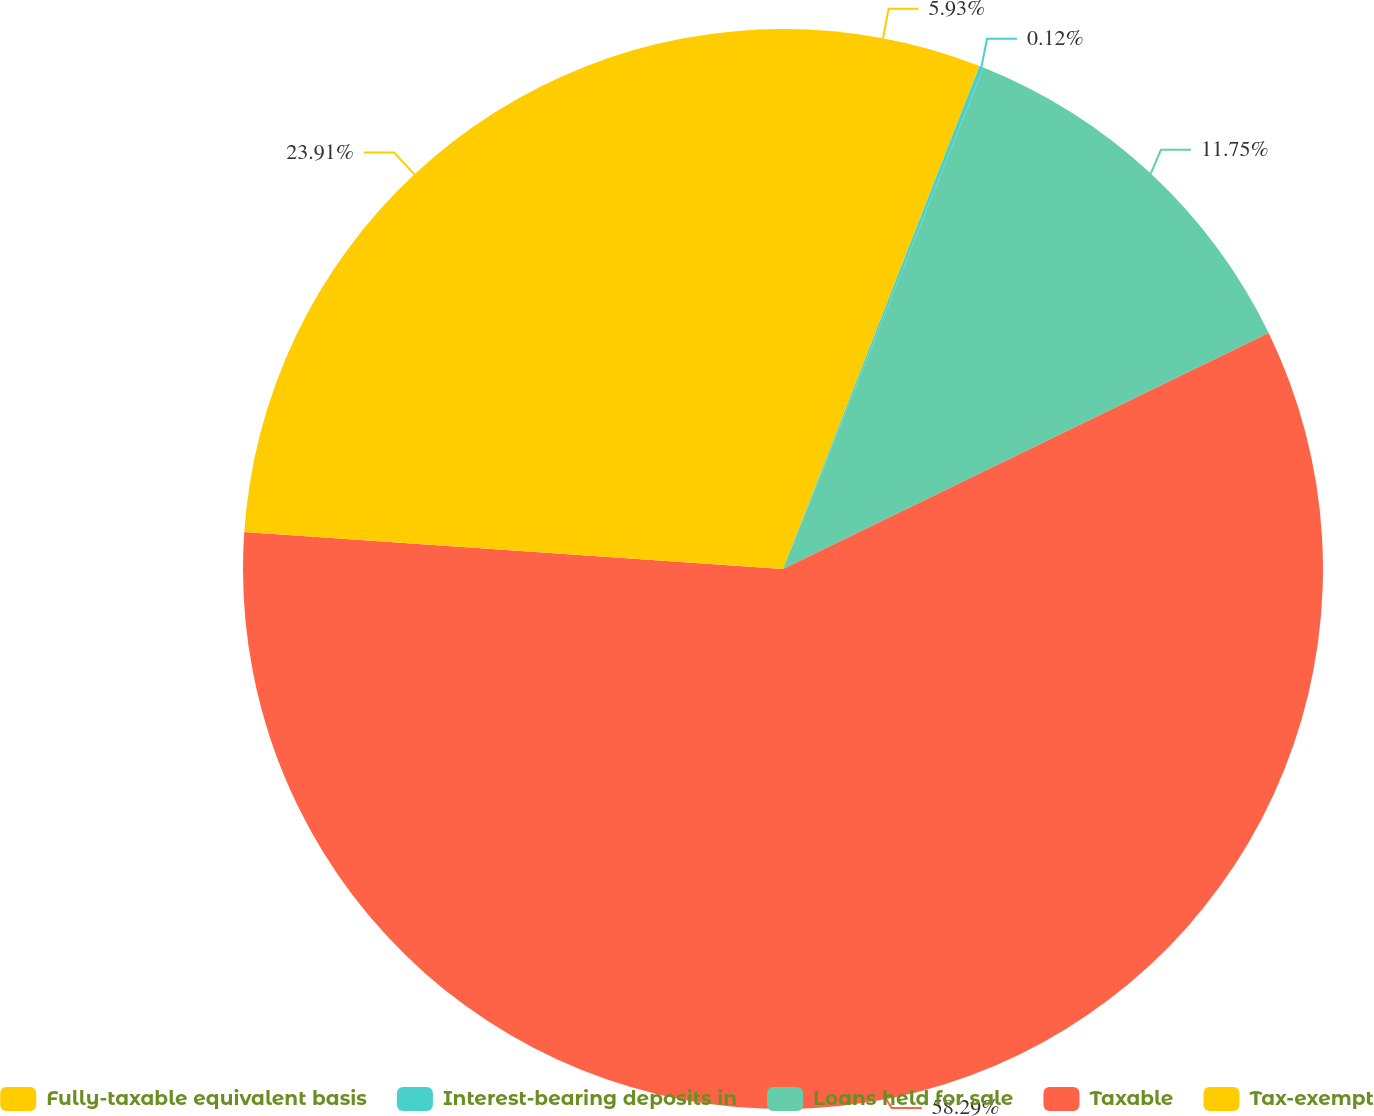Convert chart to OTSL. <chart><loc_0><loc_0><loc_500><loc_500><pie_chart><fcel>Fully-taxable equivalent basis<fcel>Interest-bearing deposits in<fcel>Loans held for sale<fcel>Taxable<fcel>Tax-exempt<nl><fcel>5.93%<fcel>0.12%<fcel>11.75%<fcel>58.29%<fcel>23.91%<nl></chart> 